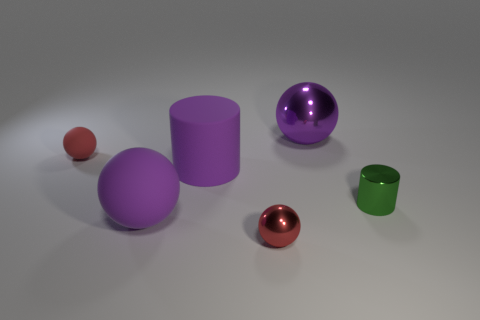Subtract 1 balls. How many balls are left? 3 Add 2 small purple rubber blocks. How many objects exist? 8 Subtract all cylinders. How many objects are left? 4 Subtract all large purple rubber cylinders. Subtract all big red metal cylinders. How many objects are left? 5 Add 6 rubber cylinders. How many rubber cylinders are left? 7 Add 6 small blue matte cylinders. How many small blue matte cylinders exist? 6 Subtract 0 red cylinders. How many objects are left? 6 